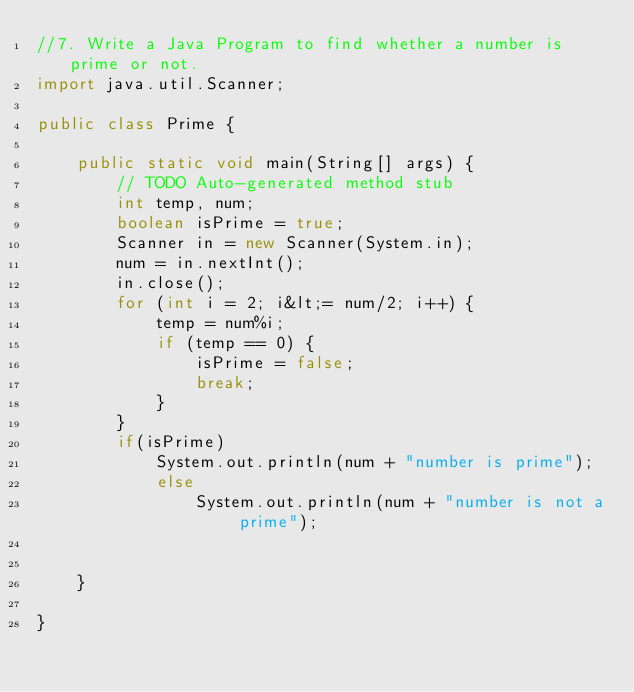Convert code to text. <code><loc_0><loc_0><loc_500><loc_500><_Java_>//7. Write a Java Program to find whether a number is prime or not.
import java.util.Scanner;
 
public class Prime {
 
    public static void main(String[] args) {
        // TODO Auto-generated method stub
        int temp, num;
        boolean isPrime = true;
        Scanner in = new Scanner(System.in);
        num = in.nextInt();
        in.close();
        for (int i = 2; i&lt;= num/2; i++) {
            temp = num%i;
            if (temp == 0) {
                isPrime = false;
                break;
            }
        }
        if(isPrime) 
            System.out.println(num + "number is prime");
            else
                System.out.println(num + "number is not a prime");
             
         
    }
 
}
</code> 